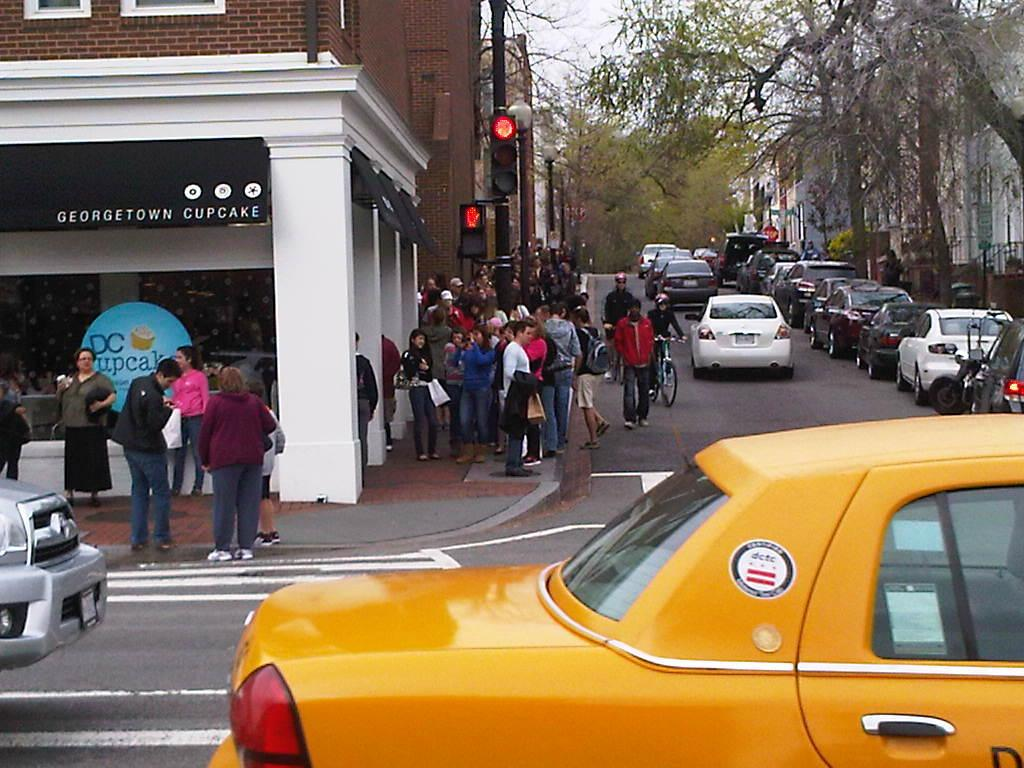Provide a one-sentence caption for the provided image. A group of people are standing outside of a cupcake store. 